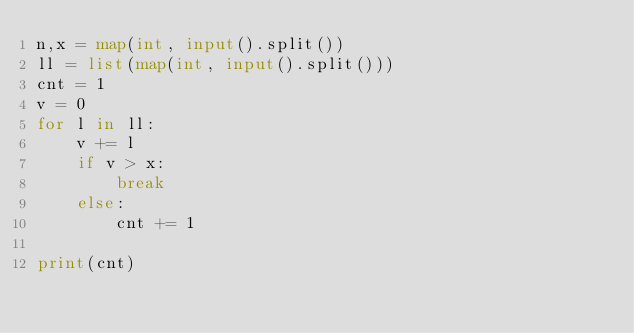Convert code to text. <code><loc_0><loc_0><loc_500><loc_500><_Python_>n,x = map(int, input().split())
ll = list(map(int, input().split()))
cnt = 1
v = 0
for l in ll:
    v += l
    if v > x:
        break
    else:
        cnt += 1

print(cnt)</code> 